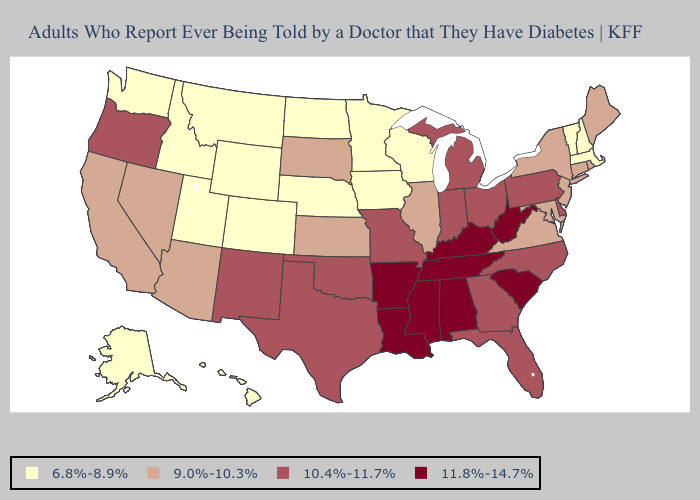What is the lowest value in the USA?
Be succinct. 6.8%-8.9%. Does Ohio have the highest value in the USA?
Quick response, please. No. Which states hav the highest value in the West?
Concise answer only. New Mexico, Oregon. What is the value of Connecticut?
Concise answer only. 9.0%-10.3%. Does Tennessee have the lowest value in the USA?
Be succinct. No. Does Rhode Island have a lower value than California?
Short answer required. No. What is the highest value in the West ?
Short answer required. 10.4%-11.7%. Does Massachusetts have the lowest value in the USA?
Concise answer only. Yes. Does the first symbol in the legend represent the smallest category?
Answer briefly. Yes. Name the states that have a value in the range 11.8%-14.7%?
Write a very short answer. Alabama, Arkansas, Kentucky, Louisiana, Mississippi, South Carolina, Tennessee, West Virginia. What is the lowest value in the West?
Concise answer only. 6.8%-8.9%. Does Oregon have the lowest value in the West?
Concise answer only. No. What is the value of Alabama?
Short answer required. 11.8%-14.7%. What is the highest value in states that border New Mexico?
Answer briefly. 10.4%-11.7%. Which states hav the highest value in the South?
Short answer required. Alabama, Arkansas, Kentucky, Louisiana, Mississippi, South Carolina, Tennessee, West Virginia. 